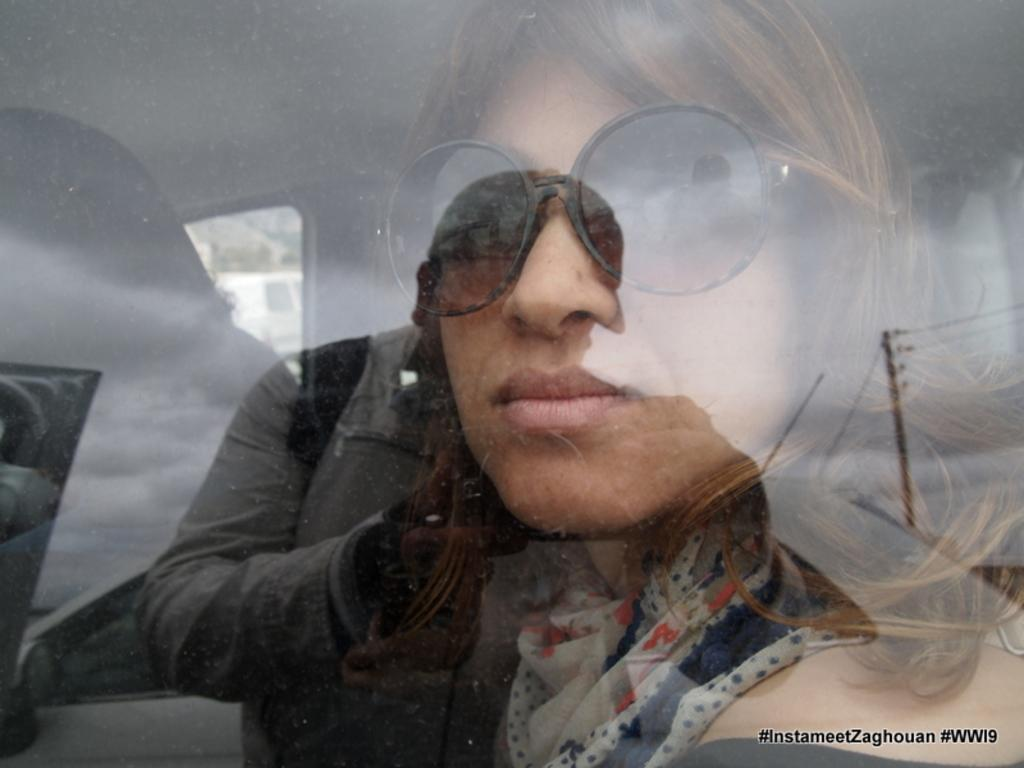What is happening in the image involving people and a vehicle? There are people sitting in a vehicle. Can you describe any additional details about the image? There is a reflection of a man holding a camera on the window glass. What type of magic is being performed by the people in the vehicle? There is no magic being performed in the image; it simply shows people sitting in a vehicle and a reflection of a man holding a camera on the window glass. 